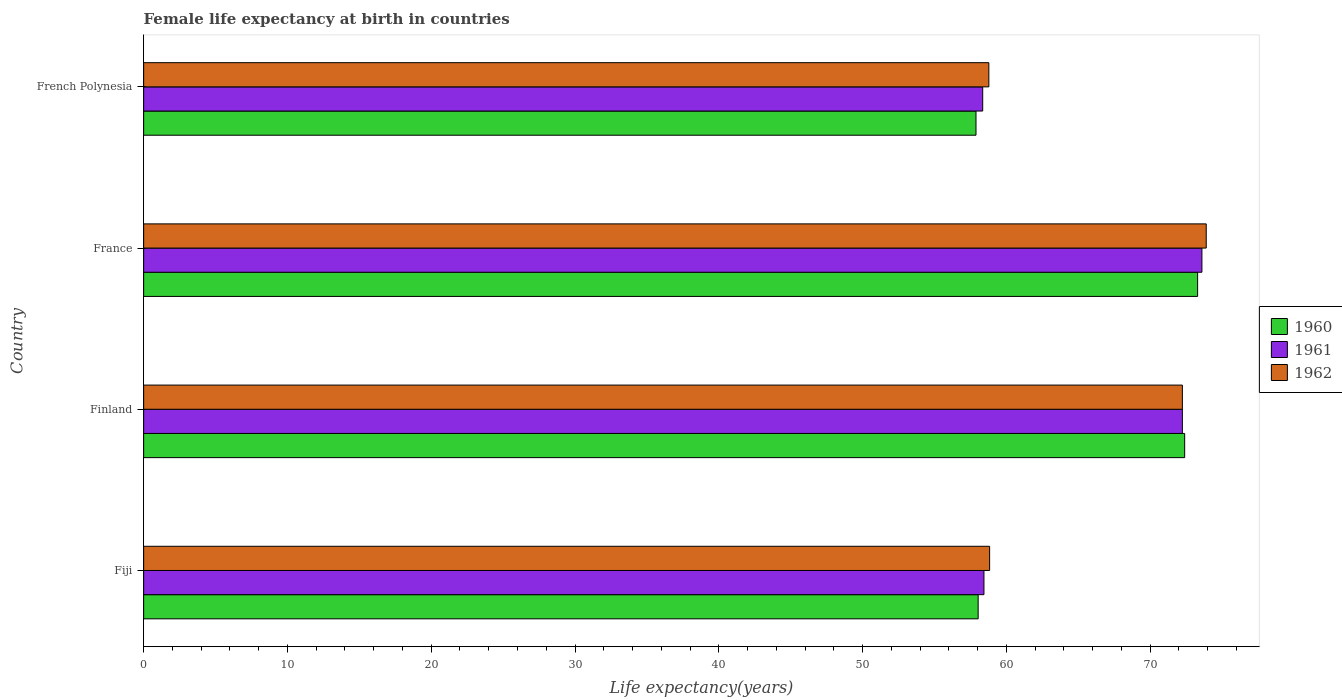How many different coloured bars are there?
Your answer should be compact. 3. How many bars are there on the 1st tick from the bottom?
Your answer should be compact. 3. What is the label of the 3rd group of bars from the top?
Your answer should be very brief. Finland. In how many cases, is the number of bars for a given country not equal to the number of legend labels?
Provide a short and direct response. 0. What is the female life expectancy at birth in 1961 in French Polynesia?
Your answer should be very brief. 58.35. Across all countries, what is the maximum female life expectancy at birth in 1960?
Keep it short and to the point. 73.3. Across all countries, what is the minimum female life expectancy at birth in 1961?
Give a very brief answer. 58.35. In which country was the female life expectancy at birth in 1960 maximum?
Provide a short and direct response. France. In which country was the female life expectancy at birth in 1962 minimum?
Offer a very short reply. French Polynesia. What is the total female life expectancy at birth in 1961 in the graph?
Provide a succinct answer. 262.63. What is the difference between the female life expectancy at birth in 1960 in Finland and that in France?
Make the answer very short. -0.9. What is the difference between the female life expectancy at birth in 1961 in French Polynesia and the female life expectancy at birth in 1960 in Finland?
Your response must be concise. -14.05. What is the average female life expectancy at birth in 1960 per country?
Your answer should be compact. 65.41. What is the difference between the female life expectancy at birth in 1961 and female life expectancy at birth in 1960 in Finland?
Ensure brevity in your answer.  -0.16. In how many countries, is the female life expectancy at birth in 1960 greater than 46 years?
Give a very brief answer. 4. What is the ratio of the female life expectancy at birth in 1961 in Finland to that in French Polynesia?
Your response must be concise. 1.24. Is the female life expectancy at birth in 1962 in Finland less than that in French Polynesia?
Your answer should be very brief. No. What is the difference between the highest and the second highest female life expectancy at birth in 1962?
Your answer should be very brief. 1.66. What is the difference between the highest and the lowest female life expectancy at birth in 1960?
Your answer should be very brief. 15.41. In how many countries, is the female life expectancy at birth in 1960 greater than the average female life expectancy at birth in 1960 taken over all countries?
Provide a short and direct response. 2. How many bars are there?
Provide a succinct answer. 12. How many countries are there in the graph?
Ensure brevity in your answer.  4. Are the values on the major ticks of X-axis written in scientific E-notation?
Your answer should be compact. No. Does the graph contain any zero values?
Your response must be concise. No. Does the graph contain grids?
Keep it short and to the point. No. Where does the legend appear in the graph?
Keep it short and to the point. Center right. How many legend labels are there?
Your answer should be very brief. 3. What is the title of the graph?
Provide a short and direct response. Female life expectancy at birth in countries. Does "2005" appear as one of the legend labels in the graph?
Keep it short and to the point. No. What is the label or title of the X-axis?
Provide a short and direct response. Life expectancy(years). What is the Life expectancy(years) in 1960 in Fiji?
Your response must be concise. 58.04. What is the Life expectancy(years) in 1961 in Fiji?
Give a very brief answer. 58.44. What is the Life expectancy(years) of 1962 in Fiji?
Your answer should be very brief. 58.84. What is the Life expectancy(years) of 1960 in Finland?
Keep it short and to the point. 72.4. What is the Life expectancy(years) in 1961 in Finland?
Give a very brief answer. 72.24. What is the Life expectancy(years) of 1962 in Finland?
Give a very brief answer. 72.24. What is the Life expectancy(years) of 1960 in France?
Your answer should be compact. 73.3. What is the Life expectancy(years) of 1961 in France?
Provide a short and direct response. 73.6. What is the Life expectancy(years) in 1962 in France?
Provide a succinct answer. 73.9. What is the Life expectancy(years) of 1960 in French Polynesia?
Keep it short and to the point. 57.89. What is the Life expectancy(years) of 1961 in French Polynesia?
Your answer should be very brief. 58.35. What is the Life expectancy(years) of 1962 in French Polynesia?
Your answer should be compact. 58.78. Across all countries, what is the maximum Life expectancy(years) in 1960?
Your response must be concise. 73.3. Across all countries, what is the maximum Life expectancy(years) in 1961?
Provide a short and direct response. 73.6. Across all countries, what is the maximum Life expectancy(years) in 1962?
Make the answer very short. 73.9. Across all countries, what is the minimum Life expectancy(years) of 1960?
Your answer should be compact. 57.89. Across all countries, what is the minimum Life expectancy(years) in 1961?
Your answer should be very brief. 58.35. Across all countries, what is the minimum Life expectancy(years) of 1962?
Ensure brevity in your answer.  58.78. What is the total Life expectancy(years) of 1960 in the graph?
Your answer should be very brief. 261.63. What is the total Life expectancy(years) of 1961 in the graph?
Give a very brief answer. 262.63. What is the total Life expectancy(years) of 1962 in the graph?
Provide a succinct answer. 263.76. What is the difference between the Life expectancy(years) of 1960 in Fiji and that in Finland?
Offer a terse response. -14.36. What is the difference between the Life expectancy(years) in 1961 in Fiji and that in Finland?
Offer a terse response. -13.8. What is the difference between the Life expectancy(years) of 1962 in Fiji and that in Finland?
Keep it short and to the point. -13.4. What is the difference between the Life expectancy(years) in 1960 in Fiji and that in France?
Provide a short and direct response. -15.26. What is the difference between the Life expectancy(years) of 1961 in Fiji and that in France?
Make the answer very short. -15.16. What is the difference between the Life expectancy(years) in 1962 in Fiji and that in France?
Ensure brevity in your answer.  -15.06. What is the difference between the Life expectancy(years) in 1961 in Fiji and that in French Polynesia?
Offer a very short reply. 0.09. What is the difference between the Life expectancy(years) in 1962 in Fiji and that in French Polynesia?
Ensure brevity in your answer.  0.05. What is the difference between the Life expectancy(years) of 1960 in Finland and that in France?
Your answer should be compact. -0.9. What is the difference between the Life expectancy(years) in 1961 in Finland and that in France?
Your answer should be compact. -1.36. What is the difference between the Life expectancy(years) in 1962 in Finland and that in France?
Offer a terse response. -1.66. What is the difference between the Life expectancy(years) in 1960 in Finland and that in French Polynesia?
Your answer should be compact. 14.51. What is the difference between the Life expectancy(years) of 1961 in Finland and that in French Polynesia?
Make the answer very short. 13.89. What is the difference between the Life expectancy(years) in 1962 in Finland and that in French Polynesia?
Make the answer very short. 13.46. What is the difference between the Life expectancy(years) in 1960 in France and that in French Polynesia?
Provide a short and direct response. 15.41. What is the difference between the Life expectancy(years) in 1961 in France and that in French Polynesia?
Provide a succinct answer. 15.25. What is the difference between the Life expectancy(years) of 1962 in France and that in French Polynesia?
Provide a succinct answer. 15.12. What is the difference between the Life expectancy(years) of 1960 in Fiji and the Life expectancy(years) of 1961 in Finland?
Keep it short and to the point. -14.2. What is the difference between the Life expectancy(years) of 1960 in Fiji and the Life expectancy(years) of 1962 in Finland?
Your answer should be compact. -14.2. What is the difference between the Life expectancy(years) in 1961 in Fiji and the Life expectancy(years) in 1962 in Finland?
Your answer should be very brief. -13.8. What is the difference between the Life expectancy(years) of 1960 in Fiji and the Life expectancy(years) of 1961 in France?
Give a very brief answer. -15.56. What is the difference between the Life expectancy(years) of 1960 in Fiji and the Life expectancy(years) of 1962 in France?
Your response must be concise. -15.86. What is the difference between the Life expectancy(years) of 1961 in Fiji and the Life expectancy(years) of 1962 in France?
Offer a very short reply. -15.46. What is the difference between the Life expectancy(years) of 1960 in Fiji and the Life expectancy(years) of 1961 in French Polynesia?
Your answer should be compact. -0.32. What is the difference between the Life expectancy(years) in 1960 in Fiji and the Life expectancy(years) in 1962 in French Polynesia?
Offer a very short reply. -0.74. What is the difference between the Life expectancy(years) of 1961 in Fiji and the Life expectancy(years) of 1962 in French Polynesia?
Provide a short and direct response. -0.34. What is the difference between the Life expectancy(years) in 1961 in Finland and the Life expectancy(years) in 1962 in France?
Give a very brief answer. -1.66. What is the difference between the Life expectancy(years) in 1960 in Finland and the Life expectancy(years) in 1961 in French Polynesia?
Provide a succinct answer. 14.05. What is the difference between the Life expectancy(years) of 1960 in Finland and the Life expectancy(years) of 1962 in French Polynesia?
Ensure brevity in your answer.  13.62. What is the difference between the Life expectancy(years) in 1961 in Finland and the Life expectancy(years) in 1962 in French Polynesia?
Give a very brief answer. 13.46. What is the difference between the Life expectancy(years) in 1960 in France and the Life expectancy(years) in 1961 in French Polynesia?
Your answer should be very brief. 14.95. What is the difference between the Life expectancy(years) of 1960 in France and the Life expectancy(years) of 1962 in French Polynesia?
Keep it short and to the point. 14.52. What is the difference between the Life expectancy(years) in 1961 in France and the Life expectancy(years) in 1962 in French Polynesia?
Offer a terse response. 14.82. What is the average Life expectancy(years) in 1960 per country?
Make the answer very short. 65.41. What is the average Life expectancy(years) in 1961 per country?
Ensure brevity in your answer.  65.66. What is the average Life expectancy(years) of 1962 per country?
Offer a terse response. 65.94. What is the difference between the Life expectancy(years) of 1960 and Life expectancy(years) of 1961 in Fiji?
Keep it short and to the point. -0.4. What is the difference between the Life expectancy(years) in 1960 and Life expectancy(years) in 1962 in Fiji?
Ensure brevity in your answer.  -0.8. What is the difference between the Life expectancy(years) of 1961 and Life expectancy(years) of 1962 in Fiji?
Your answer should be very brief. -0.39. What is the difference between the Life expectancy(years) in 1960 and Life expectancy(years) in 1961 in Finland?
Offer a very short reply. 0.16. What is the difference between the Life expectancy(years) in 1960 and Life expectancy(years) in 1962 in Finland?
Give a very brief answer. 0.16. What is the difference between the Life expectancy(years) in 1961 and Life expectancy(years) in 1962 in France?
Ensure brevity in your answer.  -0.3. What is the difference between the Life expectancy(years) in 1960 and Life expectancy(years) in 1961 in French Polynesia?
Offer a terse response. -0.47. What is the difference between the Life expectancy(years) in 1960 and Life expectancy(years) in 1962 in French Polynesia?
Your answer should be compact. -0.89. What is the difference between the Life expectancy(years) in 1961 and Life expectancy(years) in 1962 in French Polynesia?
Provide a short and direct response. -0.43. What is the ratio of the Life expectancy(years) in 1960 in Fiji to that in Finland?
Your answer should be very brief. 0.8. What is the ratio of the Life expectancy(years) in 1961 in Fiji to that in Finland?
Make the answer very short. 0.81. What is the ratio of the Life expectancy(years) in 1962 in Fiji to that in Finland?
Give a very brief answer. 0.81. What is the ratio of the Life expectancy(years) of 1960 in Fiji to that in France?
Provide a succinct answer. 0.79. What is the ratio of the Life expectancy(years) in 1961 in Fiji to that in France?
Provide a short and direct response. 0.79. What is the ratio of the Life expectancy(years) of 1962 in Fiji to that in France?
Give a very brief answer. 0.8. What is the ratio of the Life expectancy(years) in 1962 in Fiji to that in French Polynesia?
Provide a short and direct response. 1. What is the ratio of the Life expectancy(years) in 1961 in Finland to that in France?
Ensure brevity in your answer.  0.98. What is the ratio of the Life expectancy(years) of 1962 in Finland to that in France?
Offer a terse response. 0.98. What is the ratio of the Life expectancy(years) of 1960 in Finland to that in French Polynesia?
Your answer should be very brief. 1.25. What is the ratio of the Life expectancy(years) of 1961 in Finland to that in French Polynesia?
Provide a succinct answer. 1.24. What is the ratio of the Life expectancy(years) of 1962 in Finland to that in French Polynesia?
Offer a very short reply. 1.23. What is the ratio of the Life expectancy(years) in 1960 in France to that in French Polynesia?
Provide a succinct answer. 1.27. What is the ratio of the Life expectancy(years) of 1961 in France to that in French Polynesia?
Provide a succinct answer. 1.26. What is the ratio of the Life expectancy(years) in 1962 in France to that in French Polynesia?
Offer a terse response. 1.26. What is the difference between the highest and the second highest Life expectancy(years) in 1961?
Your answer should be compact. 1.36. What is the difference between the highest and the second highest Life expectancy(years) in 1962?
Your answer should be compact. 1.66. What is the difference between the highest and the lowest Life expectancy(years) in 1960?
Your response must be concise. 15.41. What is the difference between the highest and the lowest Life expectancy(years) of 1961?
Keep it short and to the point. 15.25. What is the difference between the highest and the lowest Life expectancy(years) of 1962?
Make the answer very short. 15.12. 